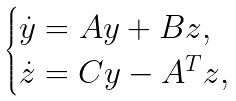<formula> <loc_0><loc_0><loc_500><loc_500>\begin{cases} \dot { y } = A y + B z , \\ \dot { z } = C y - A ^ { T } z , \end{cases}</formula> 